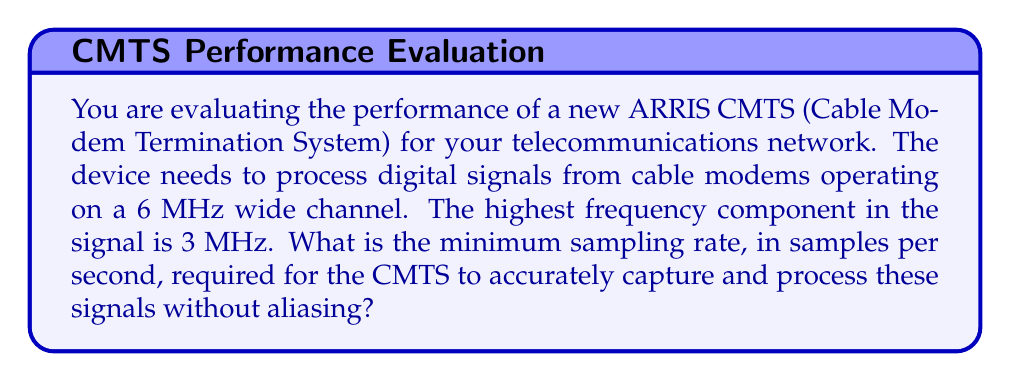Can you answer this question? To determine the minimum sampling rate for digital signal processing without aliasing, we need to apply the Nyquist-Shannon sampling theorem. This theorem states that to accurately reconstruct a signal, the sampling rate must be at least twice the highest frequency component in the signal.

Let's break down the problem and solution:

1. Identify the highest frequency component:
   The highest frequency in the signal is given as 3 MHz.

2. Apply the Nyquist-Shannon sampling theorem:
   $$f_s \geq 2f_{max}$$
   Where:
   $f_s$ = sampling frequency
   $f_{max}$ = maximum frequency component in the signal

3. Calculate the minimum sampling rate:
   $$f_s \geq 2 \times 3 \text{ MHz}$$
   $$f_s \geq 6 \text{ MHz}$$

4. Convert MHz to samples per second:
   1 MHz = 1,000,000 samples per second
   $$6 \text{ MHz} = 6 \times 1,000,000 = 6,000,000 \text{ samples per second}$$

Therefore, the minimum sampling rate required for the ARRIS CMTS to accurately capture and process these signals without aliasing is 6,000,000 samples per second or 6 Msps (Mega-samples per second).

Note: In practice, it's often recommended to use a sampling rate slightly higher than the Nyquist rate to account for non-ideal filtering and other practical considerations. However, the question asks for the minimum rate, which is precisely twice the highest frequency component.
Answer: 6,000,000 samples per second (or 6 Msps) 